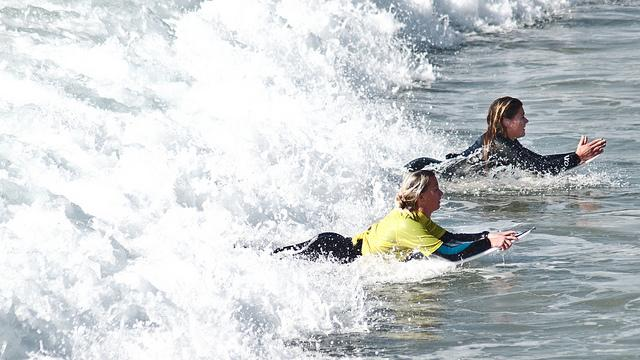What should one be good at before one begins to learn this sport?

Choices:
A) jumping
B) flipping
C) dancing
D) swimming swimming 